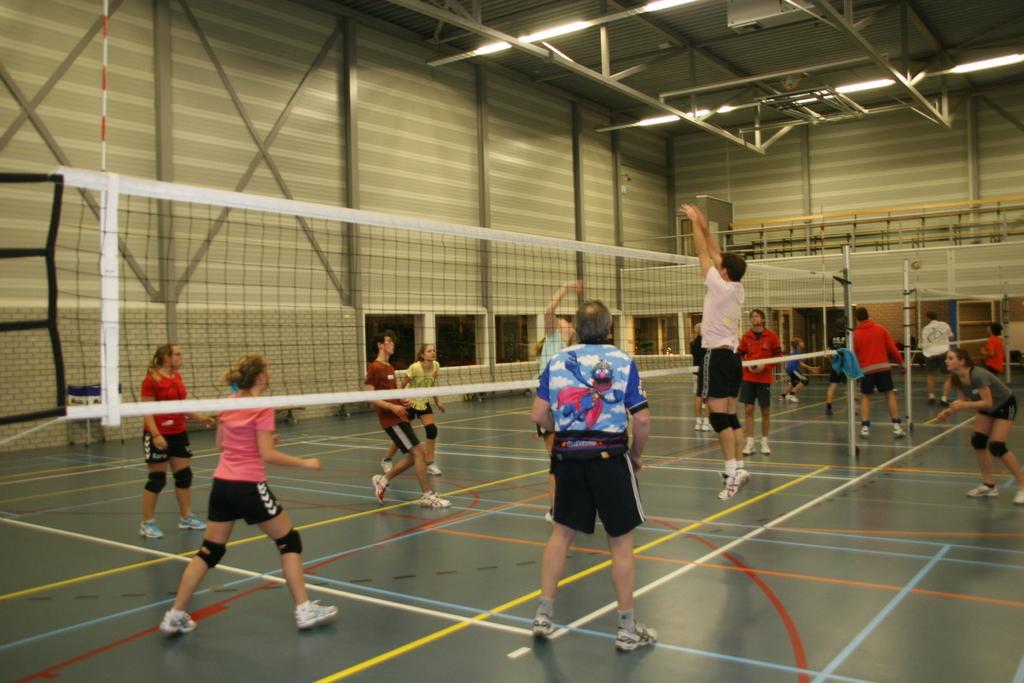Can you describe this image briefly? In this image we can see people are playing volleyball and in the middle there is a net. 